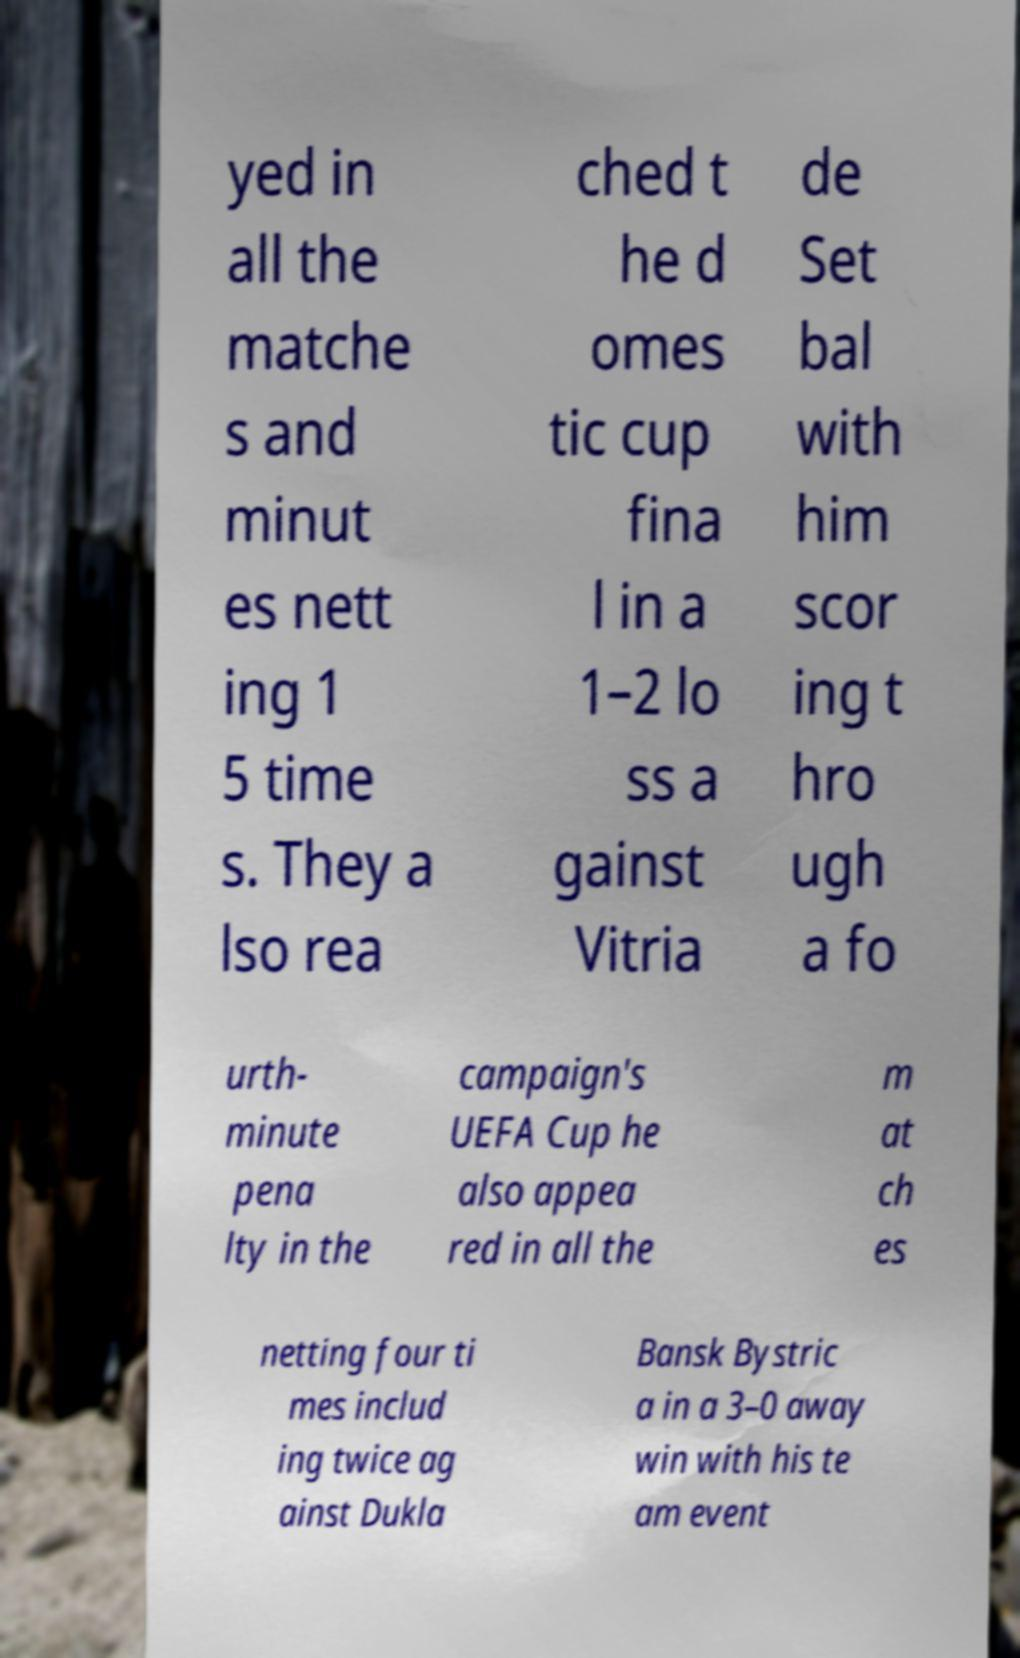For documentation purposes, I need the text within this image transcribed. Could you provide that? yed in all the matche s and minut es nett ing 1 5 time s. They a lso rea ched t he d omes tic cup fina l in a 1–2 lo ss a gainst Vitria de Set bal with him scor ing t hro ugh a fo urth- minute pena lty in the campaign's UEFA Cup he also appea red in all the m at ch es netting four ti mes includ ing twice ag ainst Dukla Bansk Bystric a in a 3–0 away win with his te am event 